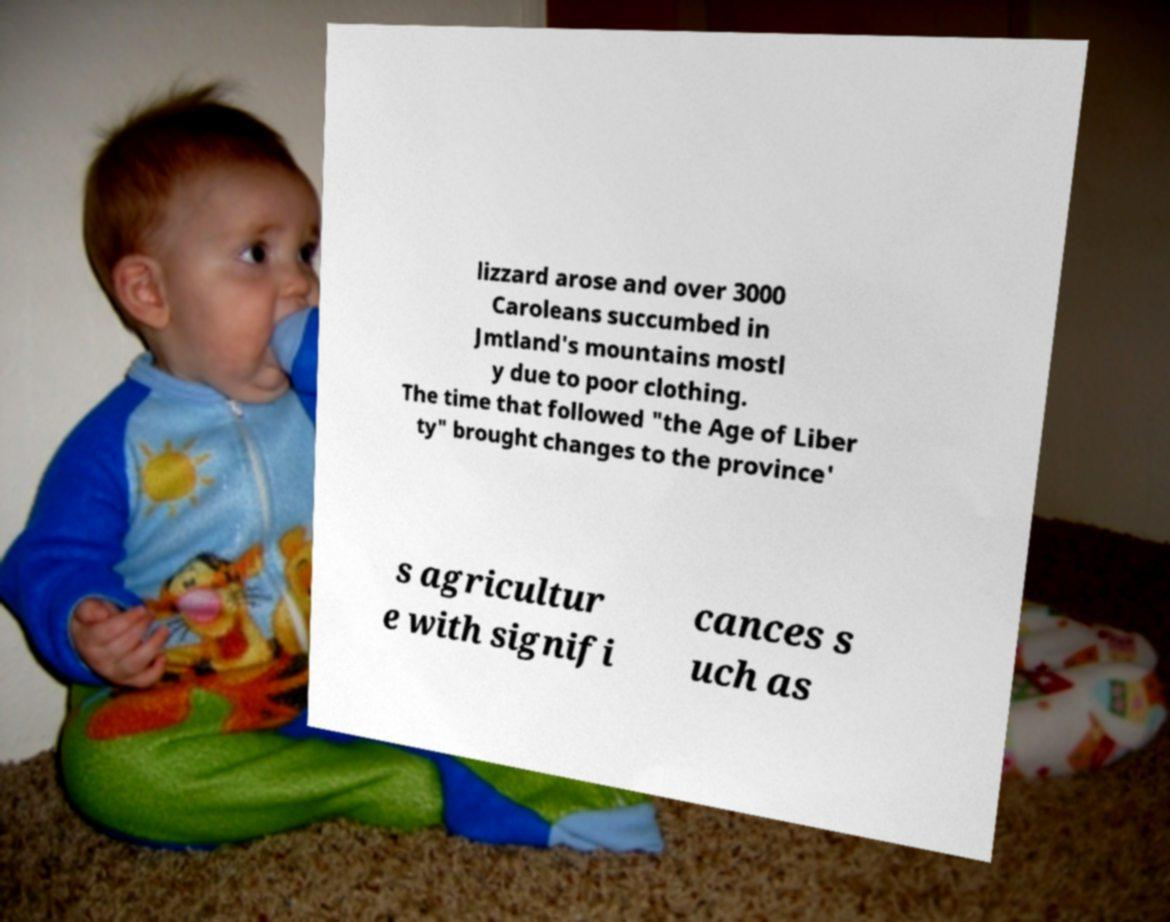Can you read and provide the text displayed in the image?This photo seems to have some interesting text. Can you extract and type it out for me? lizzard arose and over 3000 Caroleans succumbed in Jmtland's mountains mostl y due to poor clothing. The time that followed "the Age of Liber ty" brought changes to the province' s agricultur e with signifi cances s uch as 